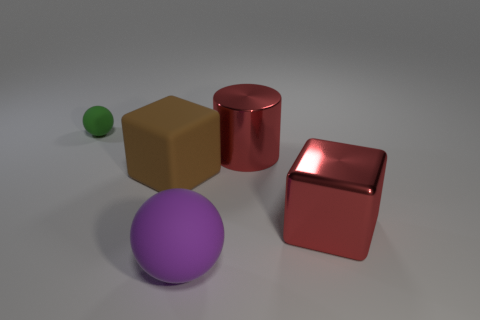Is there any other thing that has the same size as the green matte thing?
Offer a very short reply. No. There is a large cube that is to the right of the brown rubber object; does it have the same color as the cylinder?
Provide a short and direct response. Yes. There is a big matte thing behind the big purple sphere; what shape is it?
Your answer should be very brief. Cube. What color is the rubber thing behind the cube that is left of the large red thing in front of the red metal cylinder?
Give a very brief answer. Green. Are the red cylinder and the small sphere made of the same material?
Give a very brief answer. No. How many purple things are either shiny blocks or large spheres?
Give a very brief answer. 1. There is a red shiny cube; how many big purple matte things are behind it?
Your response must be concise. 0. Is the number of blue cubes greater than the number of metallic cubes?
Your answer should be very brief. No. What shape is the big red object behind the red shiny object in front of the big red cylinder?
Your answer should be compact. Cylinder. Is the big metallic cylinder the same color as the matte block?
Offer a very short reply. No. 